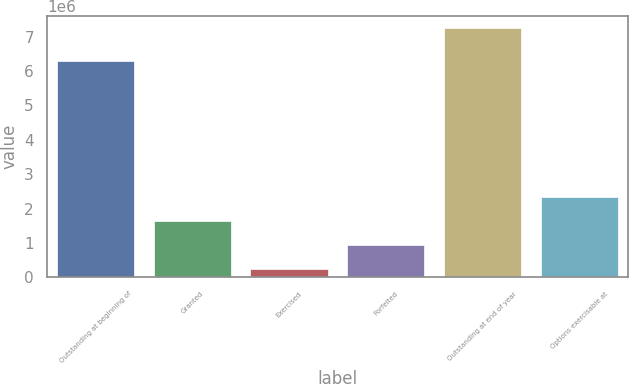<chart> <loc_0><loc_0><loc_500><loc_500><bar_chart><fcel>Outstanding at beginning of<fcel>Granted<fcel>Exercised<fcel>Forfeited<fcel>Outstanding at end of year<fcel>Options exercisable at<nl><fcel>6.30026e+06<fcel>1.6376e+06<fcel>235942<fcel>936770<fcel>7.24422e+06<fcel>2.33843e+06<nl></chart> 